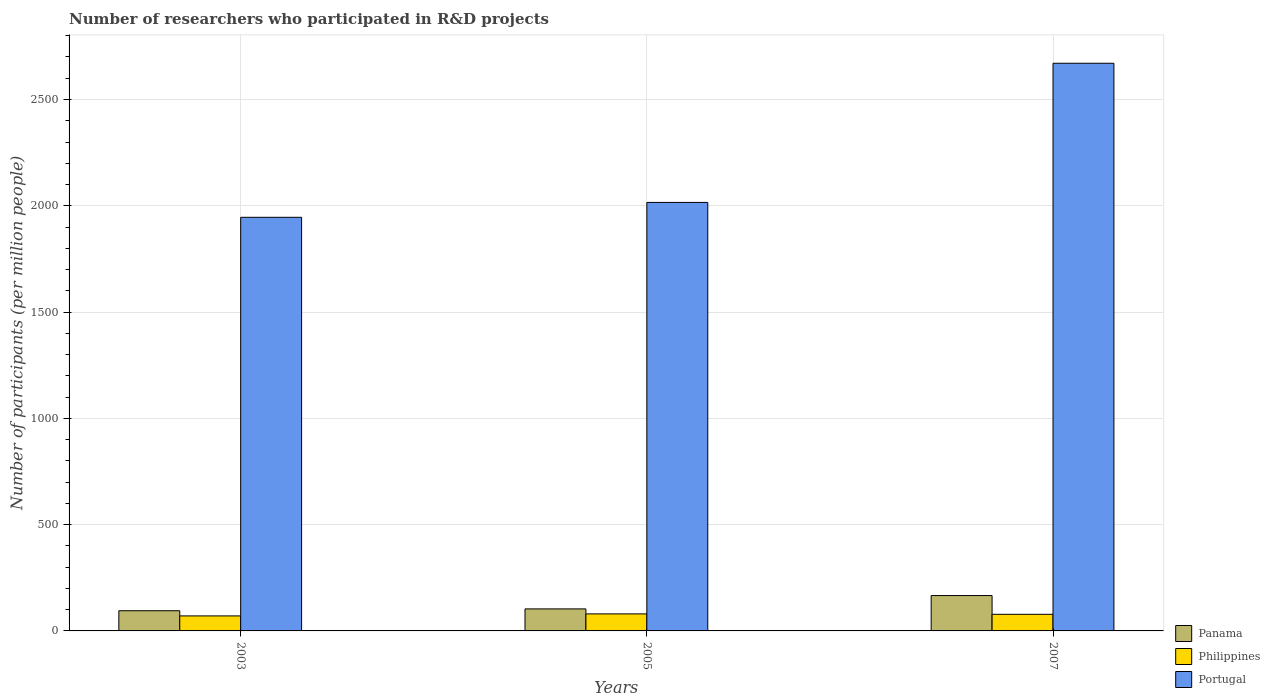How many different coloured bars are there?
Your response must be concise. 3. How many groups of bars are there?
Your answer should be very brief. 3. Are the number of bars per tick equal to the number of legend labels?
Your response must be concise. Yes. What is the number of researchers who participated in R&D projects in Portugal in 2007?
Provide a short and direct response. 2670.52. Across all years, what is the maximum number of researchers who participated in R&D projects in Philippines?
Make the answer very short. 80.05. Across all years, what is the minimum number of researchers who participated in R&D projects in Panama?
Your answer should be very brief. 94.93. In which year was the number of researchers who participated in R&D projects in Panama minimum?
Keep it short and to the point. 2003. What is the total number of researchers who participated in R&D projects in Philippines in the graph?
Offer a terse response. 228.88. What is the difference between the number of researchers who participated in R&D projects in Philippines in 2003 and that in 2007?
Provide a succinct answer. -7.57. What is the difference between the number of researchers who participated in R&D projects in Portugal in 2007 and the number of researchers who participated in R&D projects in Philippines in 2003?
Ensure brevity in your answer.  2599.9. What is the average number of researchers who participated in R&D projects in Philippines per year?
Your response must be concise. 76.29. In the year 2003, what is the difference between the number of researchers who participated in R&D projects in Philippines and number of researchers who participated in R&D projects in Panama?
Your answer should be very brief. -24.3. In how many years, is the number of researchers who participated in R&D projects in Portugal greater than 1000?
Provide a succinct answer. 3. What is the ratio of the number of researchers who participated in R&D projects in Panama in 2003 to that in 2007?
Ensure brevity in your answer.  0.57. What is the difference between the highest and the second highest number of researchers who participated in R&D projects in Portugal?
Ensure brevity in your answer.  654.68. What is the difference between the highest and the lowest number of researchers who participated in R&D projects in Portugal?
Give a very brief answer. 724.71. In how many years, is the number of researchers who participated in R&D projects in Portugal greater than the average number of researchers who participated in R&D projects in Portugal taken over all years?
Keep it short and to the point. 1. Is the sum of the number of researchers who participated in R&D projects in Portugal in 2005 and 2007 greater than the maximum number of researchers who participated in R&D projects in Panama across all years?
Provide a short and direct response. Yes. What does the 1st bar from the left in 2003 represents?
Ensure brevity in your answer.  Panama. What does the 3rd bar from the right in 2005 represents?
Keep it short and to the point. Panama. Is it the case that in every year, the sum of the number of researchers who participated in R&D projects in Portugal and number of researchers who participated in R&D projects in Panama is greater than the number of researchers who participated in R&D projects in Philippines?
Your answer should be compact. Yes. How many years are there in the graph?
Ensure brevity in your answer.  3. Are the values on the major ticks of Y-axis written in scientific E-notation?
Provide a succinct answer. No. How are the legend labels stacked?
Provide a short and direct response. Vertical. What is the title of the graph?
Provide a succinct answer. Number of researchers who participated in R&D projects. Does "East Asia (developing only)" appear as one of the legend labels in the graph?
Offer a terse response. No. What is the label or title of the X-axis?
Your answer should be very brief. Years. What is the label or title of the Y-axis?
Your answer should be compact. Number of participants (per million people). What is the Number of participants (per million people) of Panama in 2003?
Ensure brevity in your answer.  94.93. What is the Number of participants (per million people) of Philippines in 2003?
Your response must be concise. 70.63. What is the Number of participants (per million people) of Portugal in 2003?
Provide a succinct answer. 1945.82. What is the Number of participants (per million people) in Panama in 2005?
Your answer should be compact. 103.64. What is the Number of participants (per million people) of Philippines in 2005?
Give a very brief answer. 80.05. What is the Number of participants (per million people) of Portugal in 2005?
Make the answer very short. 2015.85. What is the Number of participants (per million people) in Panama in 2007?
Keep it short and to the point. 166.36. What is the Number of participants (per million people) of Philippines in 2007?
Ensure brevity in your answer.  78.2. What is the Number of participants (per million people) in Portugal in 2007?
Make the answer very short. 2670.52. Across all years, what is the maximum Number of participants (per million people) in Panama?
Provide a succinct answer. 166.36. Across all years, what is the maximum Number of participants (per million people) in Philippines?
Your answer should be very brief. 80.05. Across all years, what is the maximum Number of participants (per million people) in Portugal?
Provide a short and direct response. 2670.52. Across all years, what is the minimum Number of participants (per million people) of Panama?
Your answer should be compact. 94.93. Across all years, what is the minimum Number of participants (per million people) of Philippines?
Offer a very short reply. 70.63. Across all years, what is the minimum Number of participants (per million people) in Portugal?
Keep it short and to the point. 1945.82. What is the total Number of participants (per million people) of Panama in the graph?
Ensure brevity in your answer.  364.92. What is the total Number of participants (per million people) of Philippines in the graph?
Your answer should be compact. 228.88. What is the total Number of participants (per million people) of Portugal in the graph?
Ensure brevity in your answer.  6632.19. What is the difference between the Number of participants (per million people) of Panama in 2003 and that in 2005?
Give a very brief answer. -8.71. What is the difference between the Number of participants (per million people) in Philippines in 2003 and that in 2005?
Keep it short and to the point. -9.43. What is the difference between the Number of participants (per million people) of Portugal in 2003 and that in 2005?
Offer a very short reply. -70.03. What is the difference between the Number of participants (per million people) of Panama in 2003 and that in 2007?
Your answer should be very brief. -71.43. What is the difference between the Number of participants (per million people) of Philippines in 2003 and that in 2007?
Keep it short and to the point. -7.57. What is the difference between the Number of participants (per million people) of Portugal in 2003 and that in 2007?
Your response must be concise. -724.71. What is the difference between the Number of participants (per million people) of Panama in 2005 and that in 2007?
Provide a short and direct response. -62.72. What is the difference between the Number of participants (per million people) in Philippines in 2005 and that in 2007?
Make the answer very short. 1.86. What is the difference between the Number of participants (per million people) of Portugal in 2005 and that in 2007?
Your response must be concise. -654.68. What is the difference between the Number of participants (per million people) in Panama in 2003 and the Number of participants (per million people) in Philippines in 2005?
Provide a succinct answer. 14.87. What is the difference between the Number of participants (per million people) of Panama in 2003 and the Number of participants (per million people) of Portugal in 2005?
Provide a succinct answer. -1920.92. What is the difference between the Number of participants (per million people) in Philippines in 2003 and the Number of participants (per million people) in Portugal in 2005?
Make the answer very short. -1945.22. What is the difference between the Number of participants (per million people) in Panama in 2003 and the Number of participants (per million people) in Philippines in 2007?
Give a very brief answer. 16.73. What is the difference between the Number of participants (per million people) of Panama in 2003 and the Number of participants (per million people) of Portugal in 2007?
Make the answer very short. -2575.6. What is the difference between the Number of participants (per million people) in Philippines in 2003 and the Number of participants (per million people) in Portugal in 2007?
Ensure brevity in your answer.  -2599.9. What is the difference between the Number of participants (per million people) of Panama in 2005 and the Number of participants (per million people) of Philippines in 2007?
Give a very brief answer. 25.44. What is the difference between the Number of participants (per million people) of Panama in 2005 and the Number of participants (per million people) of Portugal in 2007?
Your response must be concise. -2566.89. What is the difference between the Number of participants (per million people) in Philippines in 2005 and the Number of participants (per million people) in Portugal in 2007?
Give a very brief answer. -2590.47. What is the average Number of participants (per million people) in Panama per year?
Your answer should be compact. 121.64. What is the average Number of participants (per million people) of Philippines per year?
Your answer should be very brief. 76.29. What is the average Number of participants (per million people) of Portugal per year?
Offer a very short reply. 2210.73. In the year 2003, what is the difference between the Number of participants (per million people) of Panama and Number of participants (per million people) of Philippines?
Make the answer very short. 24.3. In the year 2003, what is the difference between the Number of participants (per million people) in Panama and Number of participants (per million people) in Portugal?
Provide a succinct answer. -1850.89. In the year 2003, what is the difference between the Number of participants (per million people) in Philippines and Number of participants (per million people) in Portugal?
Make the answer very short. -1875.19. In the year 2005, what is the difference between the Number of participants (per million people) in Panama and Number of participants (per million people) in Philippines?
Offer a terse response. 23.58. In the year 2005, what is the difference between the Number of participants (per million people) of Panama and Number of participants (per million people) of Portugal?
Your response must be concise. -1912.21. In the year 2005, what is the difference between the Number of participants (per million people) in Philippines and Number of participants (per million people) in Portugal?
Your answer should be compact. -1935.79. In the year 2007, what is the difference between the Number of participants (per million people) in Panama and Number of participants (per million people) in Philippines?
Your answer should be compact. 88.16. In the year 2007, what is the difference between the Number of participants (per million people) in Panama and Number of participants (per million people) in Portugal?
Provide a short and direct response. -2504.17. In the year 2007, what is the difference between the Number of participants (per million people) of Philippines and Number of participants (per million people) of Portugal?
Offer a very short reply. -2592.33. What is the ratio of the Number of participants (per million people) in Panama in 2003 to that in 2005?
Make the answer very short. 0.92. What is the ratio of the Number of participants (per million people) of Philippines in 2003 to that in 2005?
Your answer should be compact. 0.88. What is the ratio of the Number of participants (per million people) of Portugal in 2003 to that in 2005?
Provide a succinct answer. 0.97. What is the ratio of the Number of participants (per million people) in Panama in 2003 to that in 2007?
Offer a terse response. 0.57. What is the ratio of the Number of participants (per million people) in Philippines in 2003 to that in 2007?
Your answer should be very brief. 0.9. What is the ratio of the Number of participants (per million people) in Portugal in 2003 to that in 2007?
Provide a short and direct response. 0.73. What is the ratio of the Number of participants (per million people) in Panama in 2005 to that in 2007?
Make the answer very short. 0.62. What is the ratio of the Number of participants (per million people) in Philippines in 2005 to that in 2007?
Offer a very short reply. 1.02. What is the ratio of the Number of participants (per million people) of Portugal in 2005 to that in 2007?
Keep it short and to the point. 0.75. What is the difference between the highest and the second highest Number of participants (per million people) in Panama?
Offer a very short reply. 62.72. What is the difference between the highest and the second highest Number of participants (per million people) of Philippines?
Make the answer very short. 1.86. What is the difference between the highest and the second highest Number of participants (per million people) of Portugal?
Your answer should be very brief. 654.68. What is the difference between the highest and the lowest Number of participants (per million people) in Panama?
Provide a succinct answer. 71.43. What is the difference between the highest and the lowest Number of participants (per million people) of Philippines?
Offer a terse response. 9.43. What is the difference between the highest and the lowest Number of participants (per million people) in Portugal?
Provide a succinct answer. 724.71. 